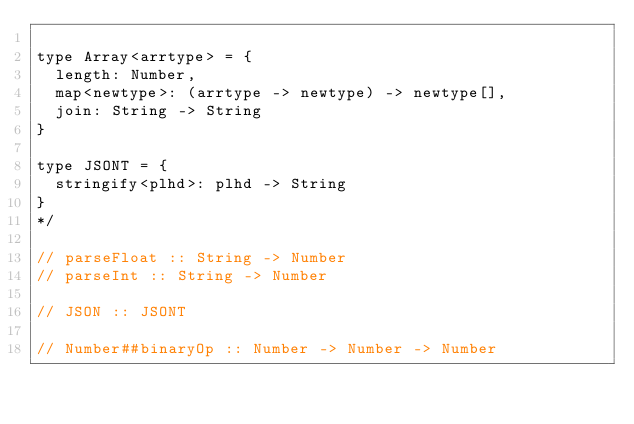Convert code to text. <code><loc_0><loc_0><loc_500><loc_500><_JavaScript_>
type Array<arrtype> = {
  length: Number,
  map<newtype>: (arrtype -> newtype) -> newtype[],
  join: String -> String
}

type JSONT = {
  stringify<plhd>: plhd -> String
}
*/

// parseFloat :: String -> Number
// parseInt :: String -> Number

// JSON :: JSONT

// Number##binaryOp :: Number -> Number -> Number
</code> 